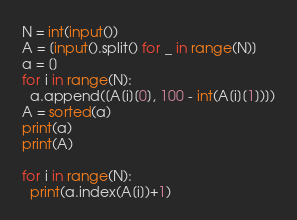Convert code to text. <code><loc_0><loc_0><loc_500><loc_500><_Python_>N = int(input())
A = [input().split() for _ in range(N)]
a = []
for i in range(N):
  a.append([A[i][0], 100 - int(A[i][1])])
A = sorted(a)
print(a)
print(A)

for i in range(N):
  print(a.index(A[i])+1)</code> 